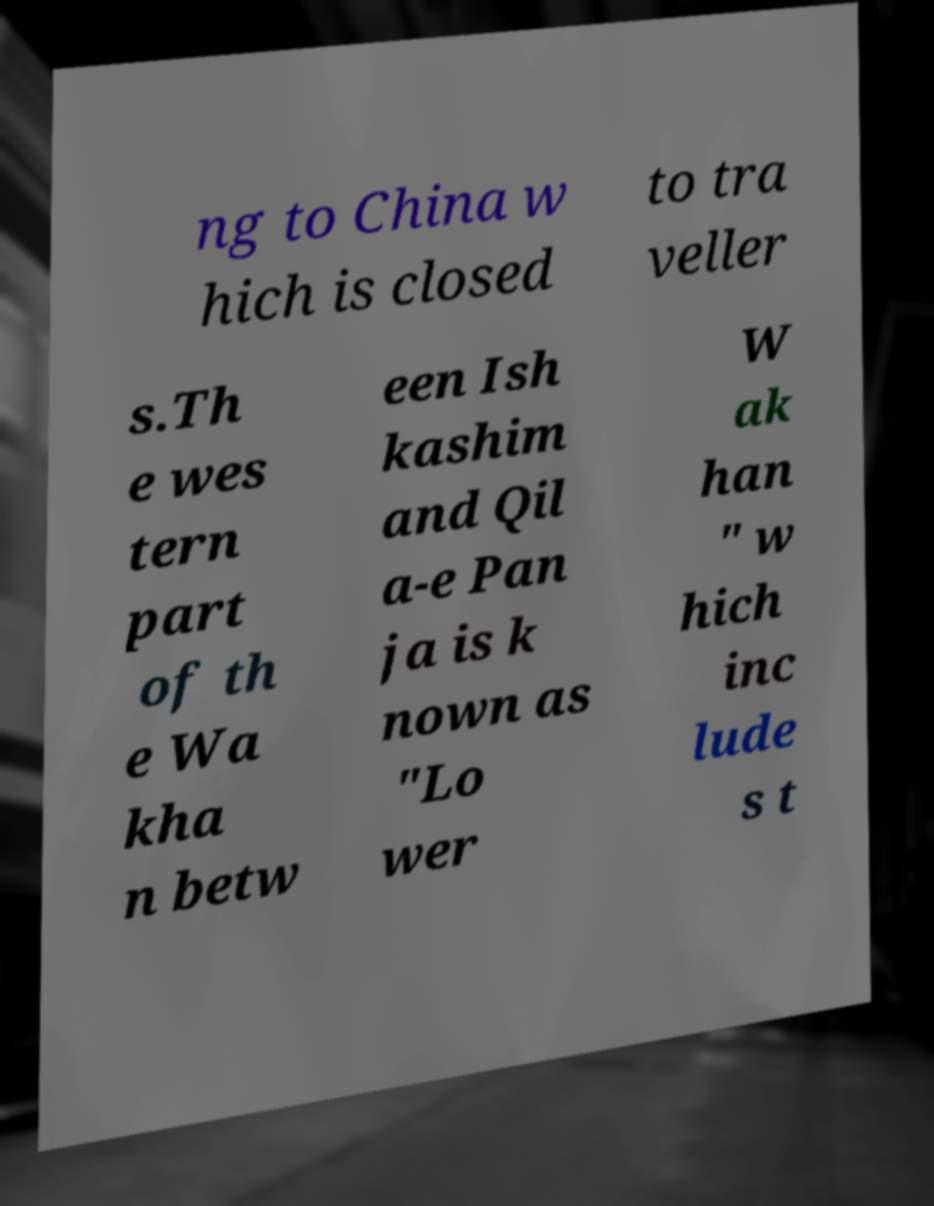For documentation purposes, I need the text within this image transcribed. Could you provide that? ng to China w hich is closed to tra veller s.Th e wes tern part of th e Wa kha n betw een Ish kashim and Qil a-e Pan ja is k nown as "Lo wer W ak han " w hich inc lude s t 